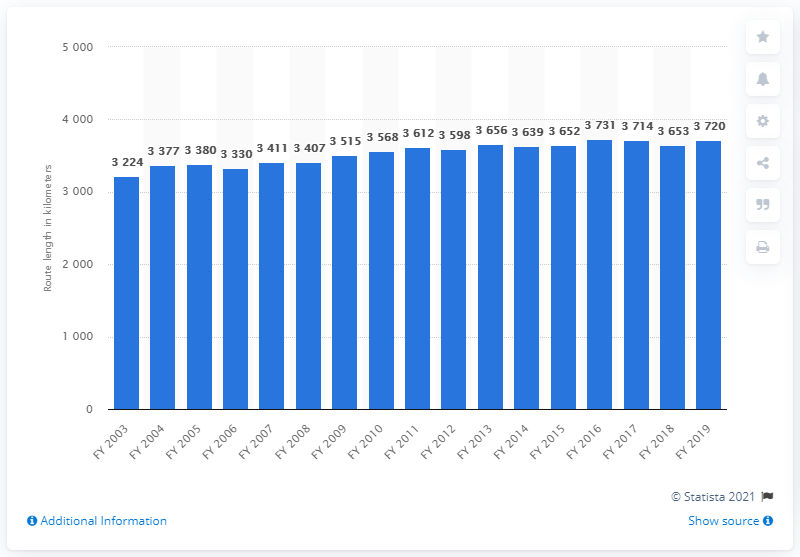Outline some significant characteristics in this image. At the end of the fiscal year 2019, the length of the railways in Bihar was 3,720 kilometers. 